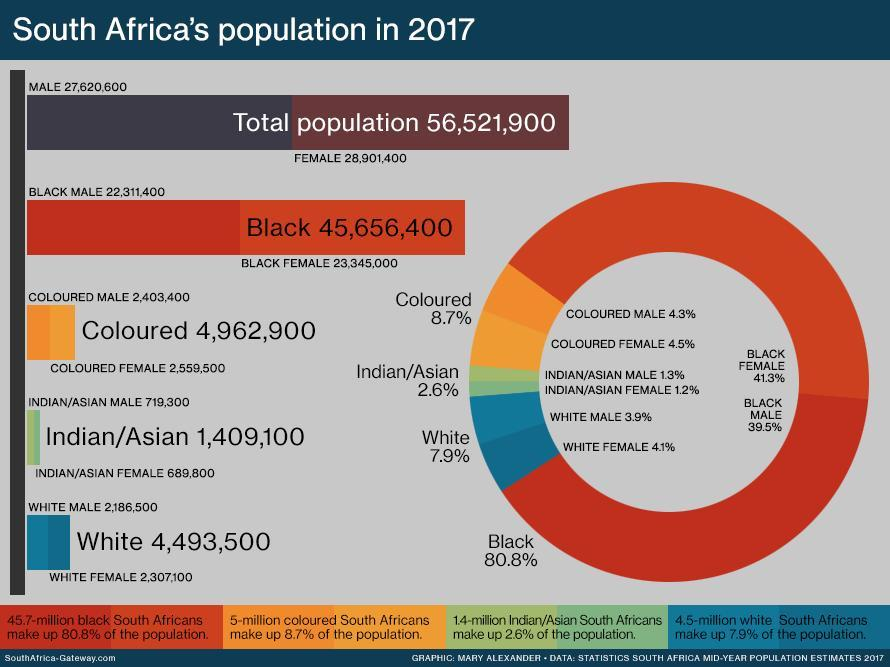What is the percentage of colored male and colored female, taken together?
Answer the question with a short phrase. 8.8% What is the percentage of Asian and colored, taken together? 11.3% What is the percentage of white males and white females, taken together? 8% What is the percentage of Asian males and Asian females, taken together? 2.5% What is the percentage of black males and black females, taken together? 80.8% What is the percentage of white and black, taken together? 88.7% 